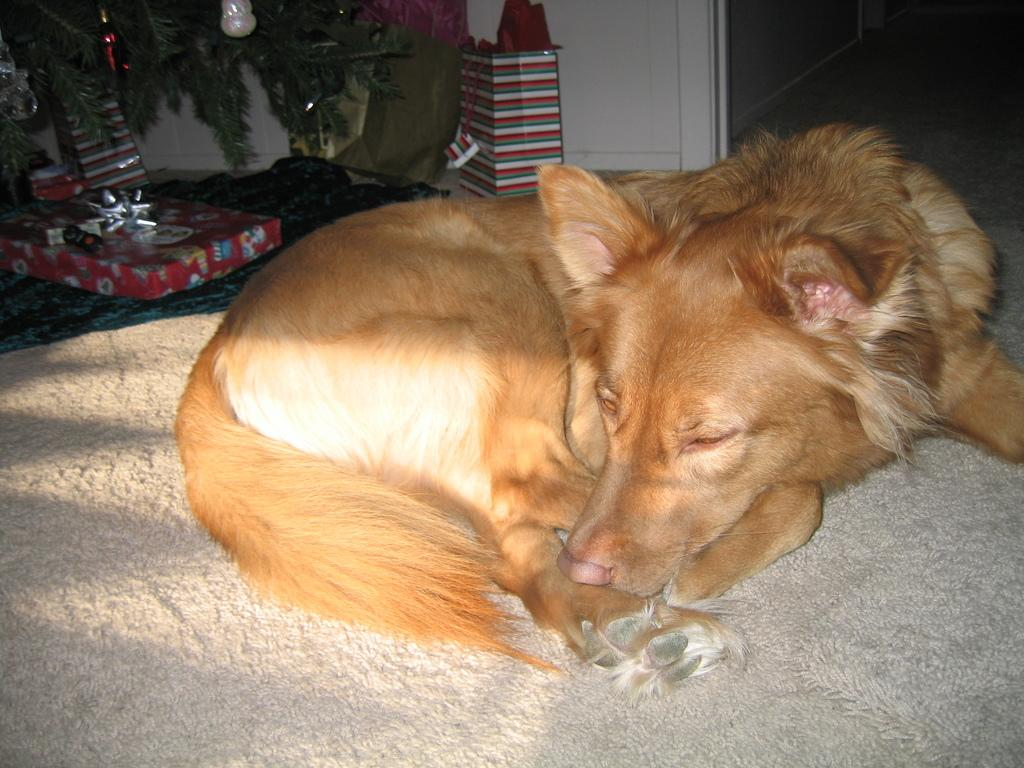What type of animal is in the image? There is a dog in the image. What color is the dog? The dog is pale brown in color. Where is the dog located in the image? The dog is on a carpet. What other objects can be seen in the image? There is a Christmas tree and gifts in the image. What part of the room is visible in the image? The floor is visible in the image. What type of soup is being served on the chessboard in the image? There is no soup or chessboard present in the image. What is the chance of winning the game of chance in the image? There is no game of chance present in the image. 